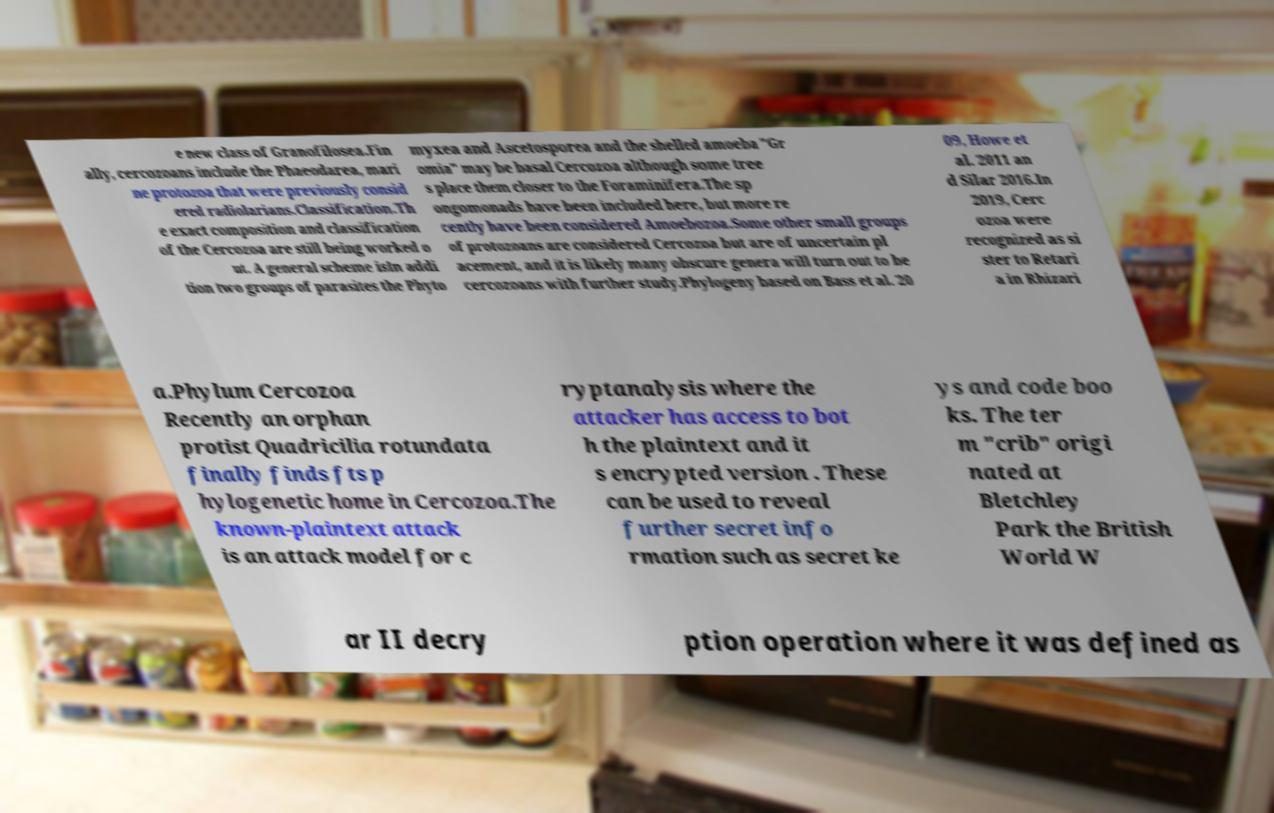Can you accurately transcribe the text from the provided image for me? e new class of Granofilosea.Fin ally, cercozoans include the Phaeodarea, mari ne protozoa that were previously consid ered radiolarians.Classification.Th e exact composition and classification of the Cercozoa are still being worked o ut. A general scheme isIn addi tion two groups of parasites the Phyto myxea and Ascetosporea and the shelled amoeba "Gr omia" may be basal Cercozoa although some tree s place them closer to the Foraminifera.The sp ongomonads have been included here, but more re cently have been considered Amoebozoa.Some other small groups of protozoans are considered Cercozoa but are of uncertain pl acement, and it is likely many obscure genera will turn out to be cercozoans with further study.Phylogeny based on Bass et al. 20 09, Howe et al. 2011 an d Silar 2016.In 2019, Cerc ozoa were recognized as si ster to Retari a in Rhizari a.Phylum Cercozoa Recently an orphan protist Quadricilia rotundata finally finds fts p hylogenetic home in Cercozoa.The known-plaintext attack is an attack model for c ryptanalysis where the attacker has access to bot h the plaintext and it s encrypted version . These can be used to reveal further secret info rmation such as secret ke ys and code boo ks. The ter m "crib" origi nated at Bletchley Park the British World W ar II decry ption operation where it was defined as 